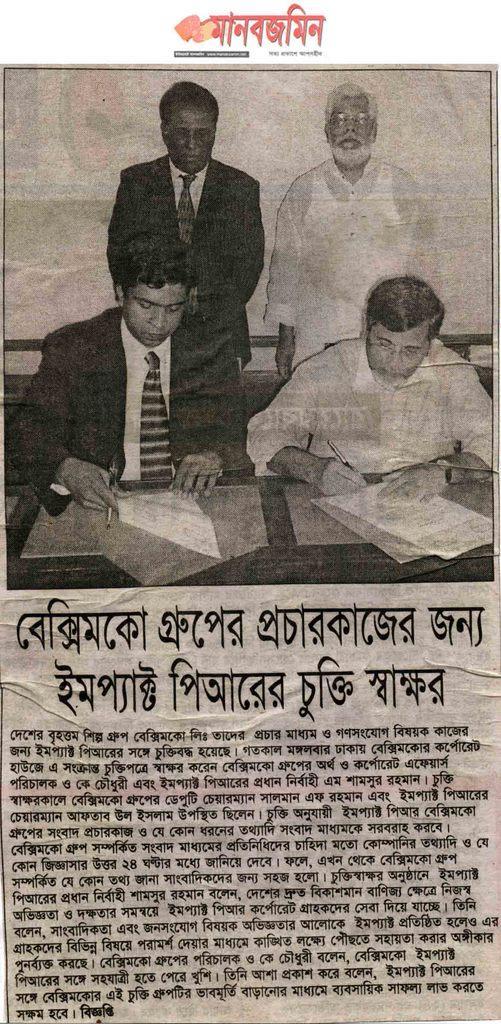Describe this image in one or two sentences. In this picture we can see a paper, on which we can see some text and image of few people. 